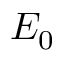<formula> <loc_0><loc_0><loc_500><loc_500>E _ { 0 }</formula> 